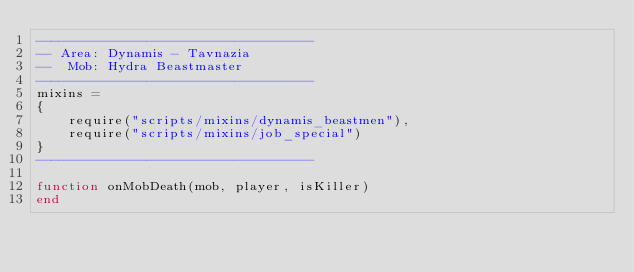Convert code to text. <code><loc_0><loc_0><loc_500><loc_500><_Lua_>-----------------------------------
-- Area: Dynamis - Tavnazia
--  Mob: Hydra Beastmaster
-----------------------------------
mixins =
{
    require("scripts/mixins/dynamis_beastmen"),
    require("scripts/mixins/job_special")
}
-----------------------------------

function onMobDeath(mob, player, isKiller)
end
</code> 